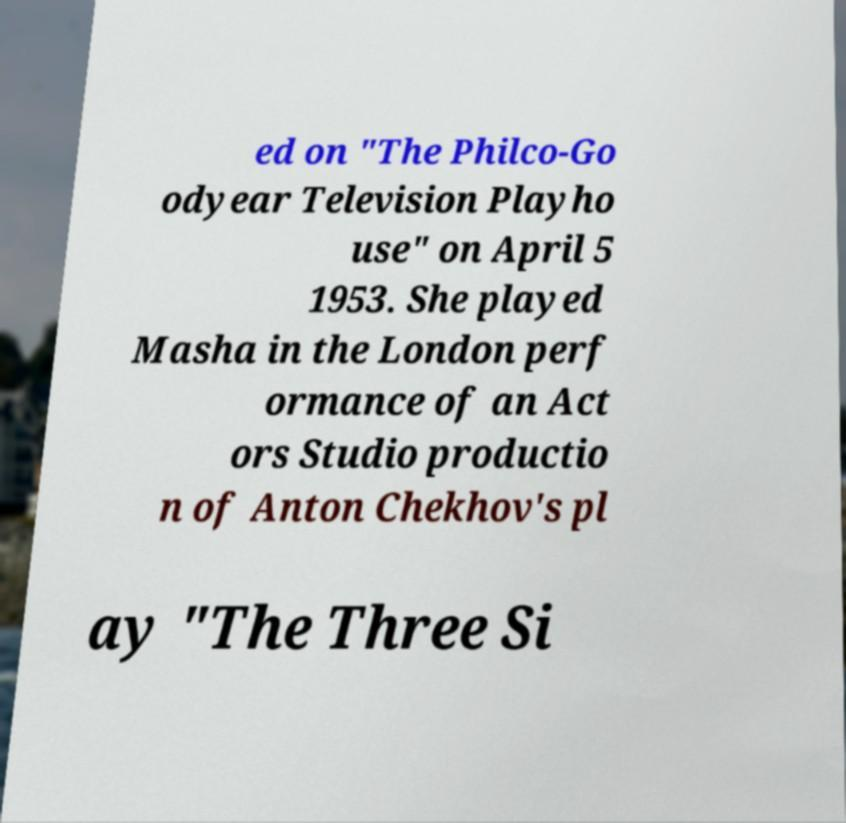Please identify and transcribe the text found in this image. ed on "The Philco-Go odyear Television Playho use" on April 5 1953. She played Masha in the London perf ormance of an Act ors Studio productio n of Anton Chekhov's pl ay "The Three Si 